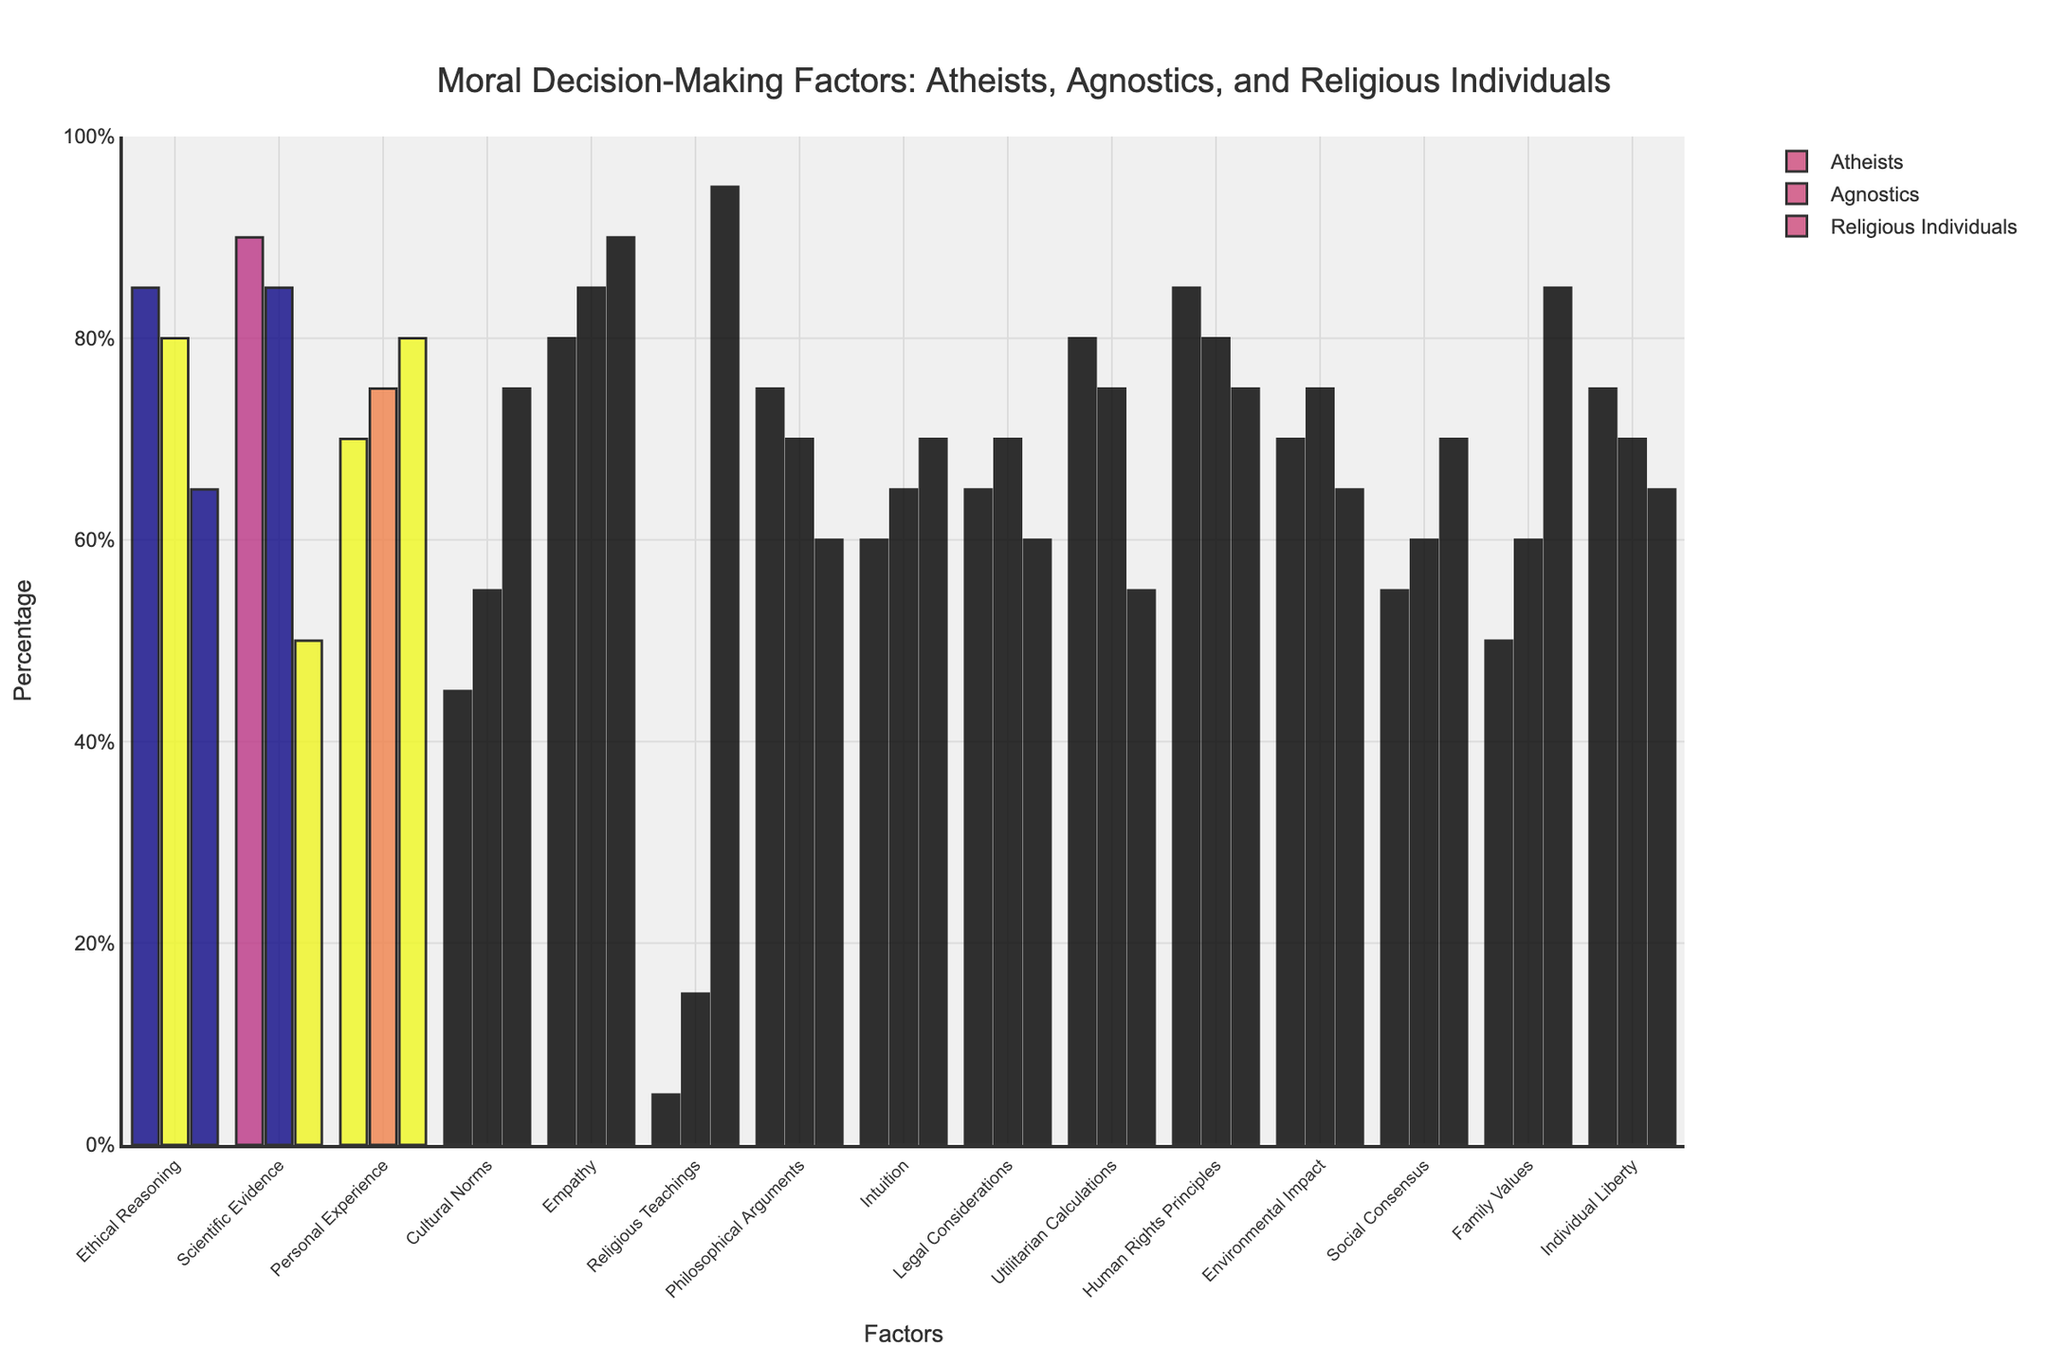What factor is equally significant for both atheists and agnostics? Ethical Reasoning is equally significant for both atheists and agnostics, as they both have values of 85 and 80 respectively.
Answer: Ethical Reasoning Which factor shows the greatest difference in significance between atheists and religious individuals? The factor "Scientific Evidence" shows the greatest difference in significance between atheists (90) and religious individuals (50), with a difference of 40 percentage points.
Answer: Scientific Evidence Which three factors have a higher percentage for religious individuals compared to atheists? By comparing the values for each factor between religious individuals and atheists, the three factors that have a higher percentage for religious individuals are Empathy (90 vs 80), Personal Experience (80 vs 70), and Religious Teachings (95 vs 5).
Answer: Empathy, Personal Experience, Religious Teachings What is the combined percentage for "Utilitarian Calculations" and "Individual Liberty" among agnostics? The combined percentage for "Utilitarian Calculations" and "Individual Liberty" among agnostics is 75 + 70 = 145.
Answer: 145 How does the emphasis on "Cultural Norms" differ among the three groups? For "Cultural Norms", atheists have 45%, agnostics have 55%, and religious individuals have 75%. This shows a trend where the importance of "Cultural Norms" increases from atheists to religious individuals.
Answer: Increases Which group pays the least attention to "Religious Teachings" and by what percentage? Atheists pay the least attention to "Religious Teachings" with a percentage of 5%.
Answer: Atheists, 5% Is "Empathy" considered more important by agnostics or religious individuals? By how much? "Empathy" is considered more important by religious individuals (90%) than by agnostics (85%), with a difference of 5 percentage points.
Answer: Religious individuals, 5% What is the average percentage of significance given to "Personal Experience" across all three groups? The percentages for "Personal Experience" are 70 (atheists), 75 (agnostics), and 80 (religious individuals). The average is (70 + 75 + 80) / 3 = 75.
Answer: 75 Look at the color coding. What color is used to represent atheists in the figure? The color used to represent atheists appears as a specific shade but without the actual figure or detailed description. We cannot determine the exact color used in this context.
Answer: Unknown Which factor is least valued by atheists and what is its percentage? "Religious Teachings" is the least valued factor by atheists, with a percentage of 5%.
Answer: Religious Teachings, 5% 